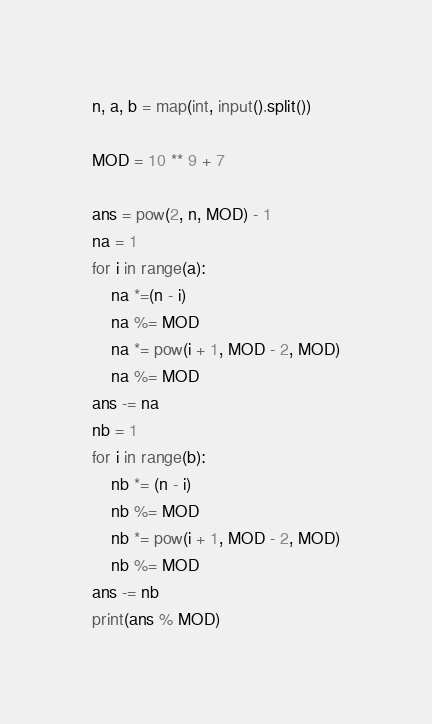<code> <loc_0><loc_0><loc_500><loc_500><_Python_>n, a, b = map(int, input().split())

MOD = 10 ** 9 + 7

ans = pow(2, n, MOD) - 1
na = 1
for i in range(a):
    na *=(n - i)
    na %= MOD
    na *= pow(i + 1, MOD - 2, MOD)
    na %= MOD
ans -= na
nb = 1
for i in range(b):
    nb *= (n - i)
    nb %= MOD
    nb *= pow(i + 1, MOD - 2, MOD)
    nb %= MOD
ans -= nb
print(ans % MOD)</code> 